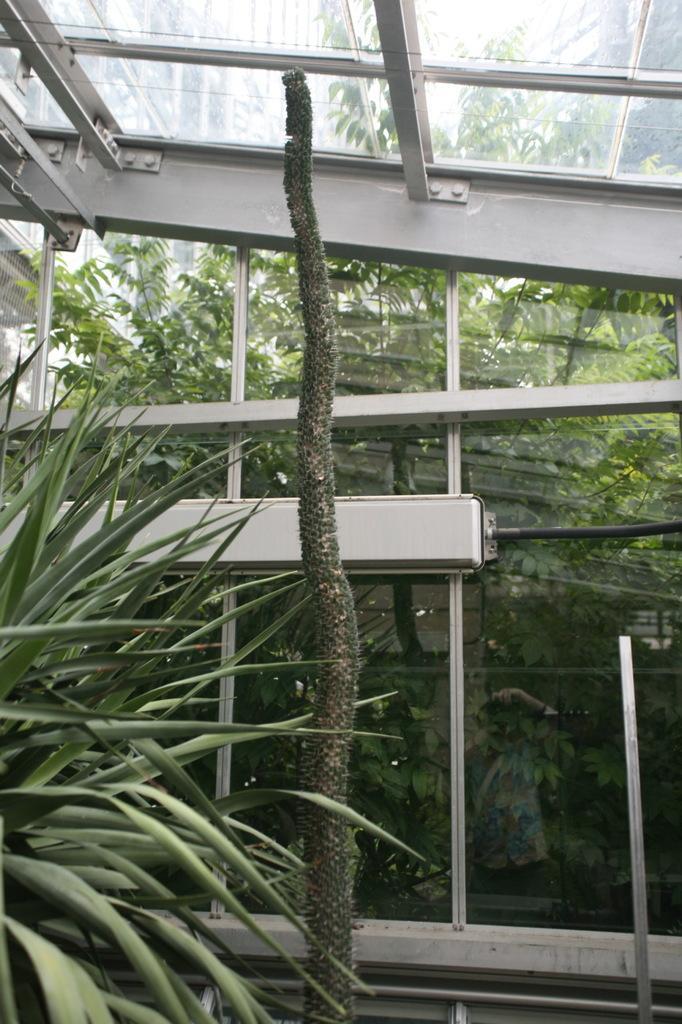Please provide a concise description of this image. In the foreground of this image, there are plants and in the background, there is a glass shed and behind it, there are trees. 